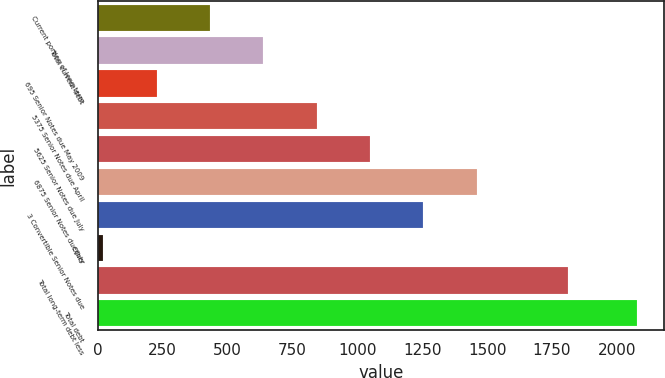<chart> <loc_0><loc_0><loc_500><loc_500><bar_chart><fcel>Current portion of long-term<fcel>Total current debt<fcel>695 Senior Notes due May 2009<fcel>5375 Senior Notes due April<fcel>5625 Senior Notes due July<fcel>6875 Senior Notes due July<fcel>3 Convertible Senior Notes due<fcel>Other<fcel>Total long-term debt less<fcel>Total debt<nl><fcel>432.12<fcel>637.63<fcel>226.61<fcel>843.14<fcel>1048.65<fcel>1459.67<fcel>1254.16<fcel>21.1<fcel>1813<fcel>2076.2<nl></chart> 